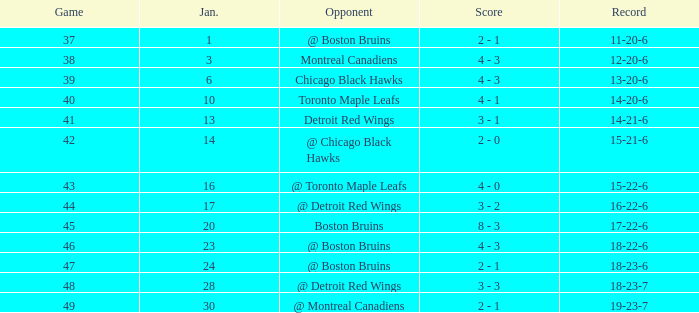What day in January was the game greater than 49 and had @ Montreal Canadiens as opponents? None. 